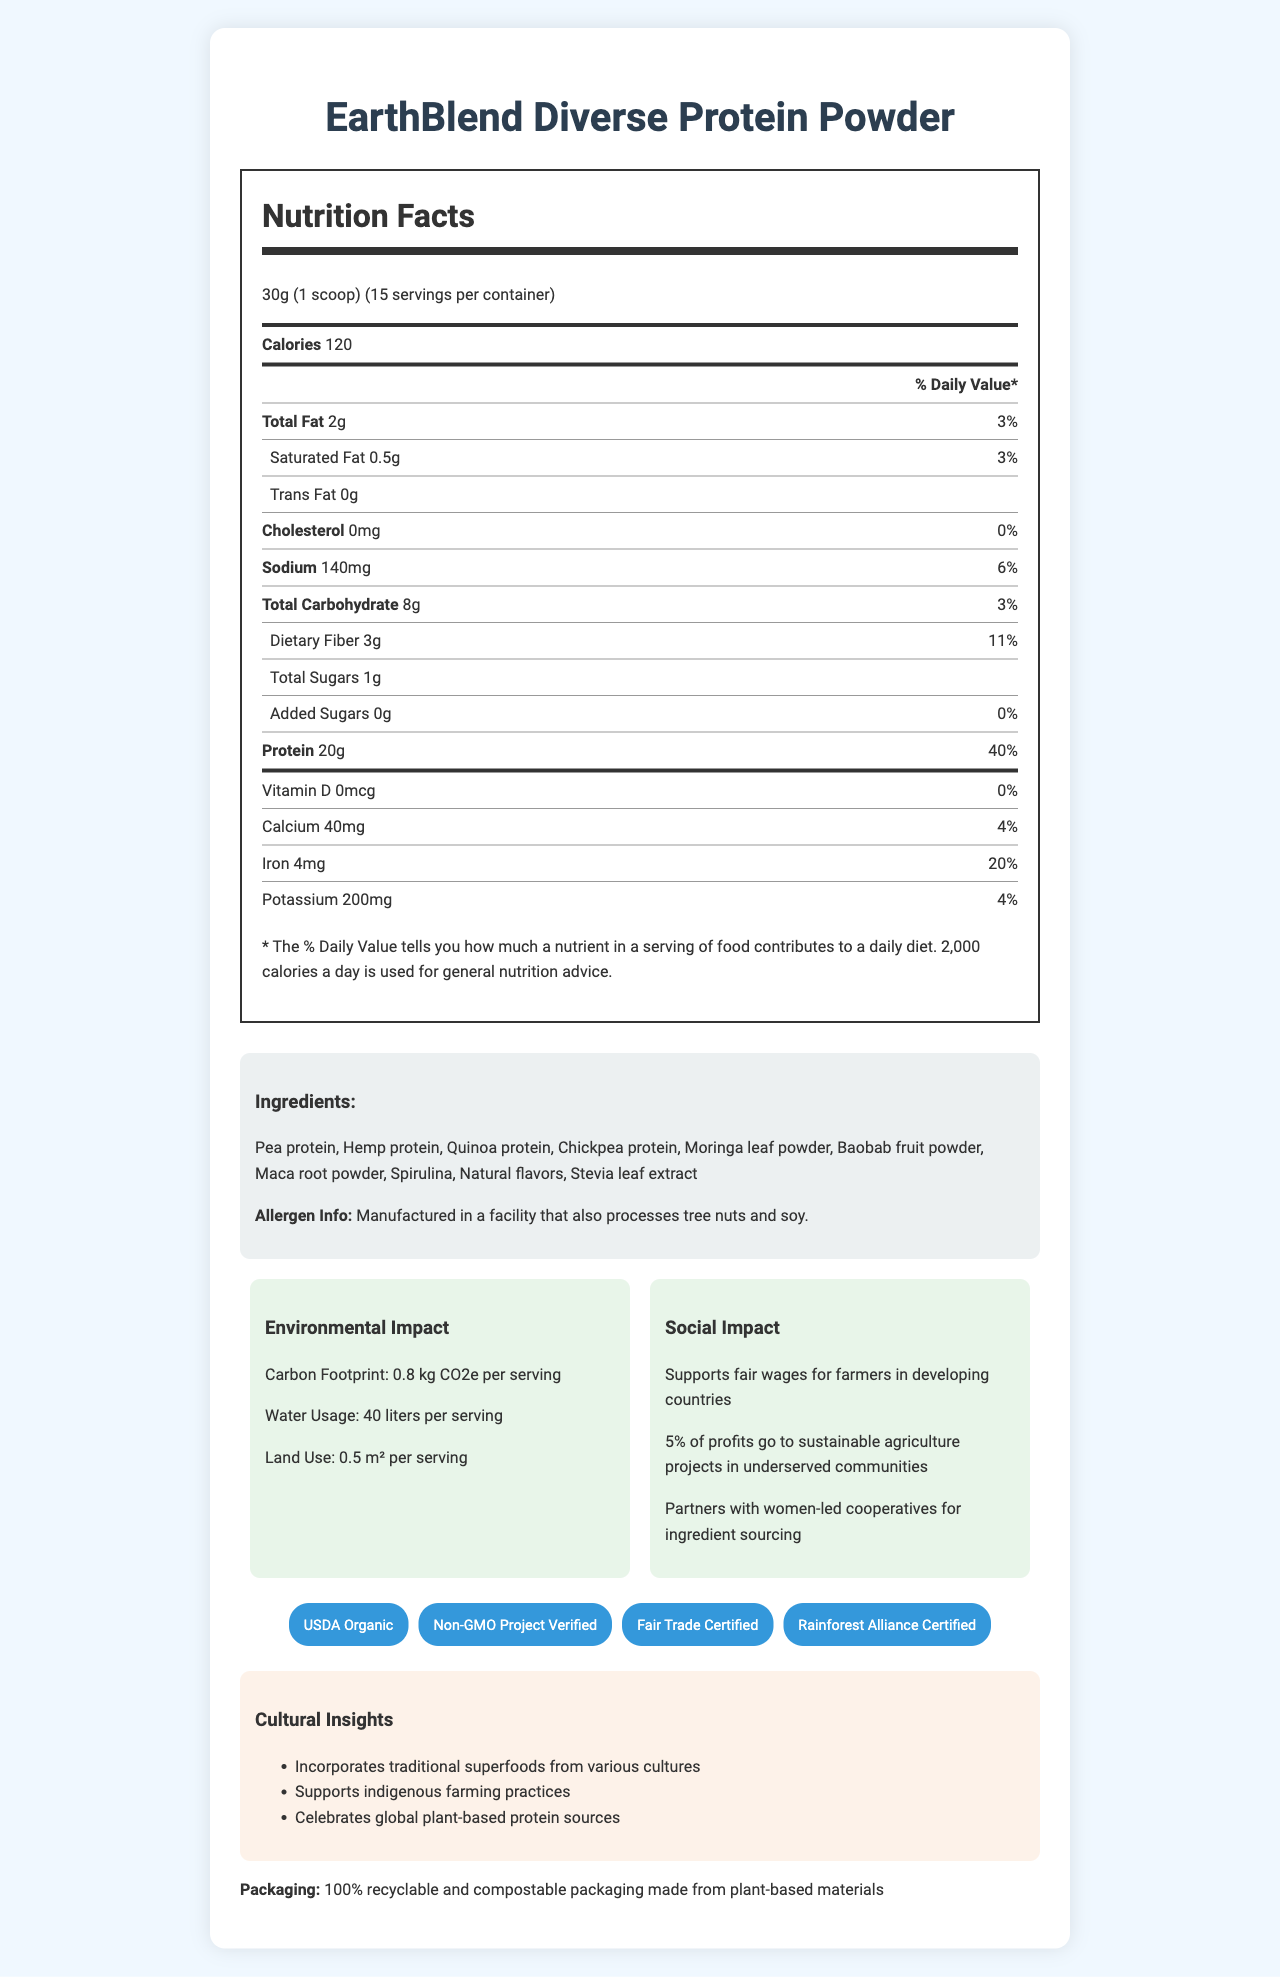what is the product called? The product name "EarthBlend Diverse Protein Powder" is clearly mentioned at the top of the document.
Answer: EarthBlend Diverse Protein Powder How many servings are in one container? The document states that there are 15 servings per container.
Answer: 15 What is the serving size? The serving size is specified as "30g (1 scoop)" in the document.
Answer: 30g (1 scoop) How many calories are there per serving? The document lists the calories per serving as 120.
Answer: 120 How much protein is in each serving? The amount of protein per serving is given as 20g in the document.
Answer: 20g Which dietary fiber percentage of daily value is provided per serving? The dietary fiber content is 3g per serving, which is 11% of the daily value.
Answer: 11% Is there any cholesterol in this product? The document states that the cholesterol amount is "0mg", indicating no cholesterol in the product.
Answer: No What is the carbon footprint per serving? The document mentions that the carbon footprint is "0.8 kg CO2e per serving".
Answer: 0.8 kg CO2e Identify the allergen information provided. The allergen info is clearly noted in the "Ingredients" section of the document.
Answer: Manufactured in a facility that also processes tree nuts and soy. Which one of these ingredients is not included in the product? A. Pea protein B. Hemp protein C. Soy protein The document lists all ingredients except soy protein.
Answer: C How much iron does one serving of the product provide? The document lists iron content as "4mg", which is 20% of the daily value.
Answer: 4mg What percentage of the daily value for calcium does one serving provide? The calcium content is 40mg, which corresponds to 4% of the daily value.
Answer: 4% Which certifications does this product have? A. USDA Organic B. Non-GMO Project Verified C. Fair Trade Certified D. Rainforest Alliance Certified E. All of the above The document lists all these certifications, so the correct answer is all of the above.
Answer: E What is the amount of total fat per serving? The document states that each serving has 2g of total fat.
Answer: 2g Does the product contain added sugars? The added sugars amount is listed as 0g, indicating no added sugars in the product.
Answer: No What initiatives does the product support for social impact? The document details these social impact initiatives in the "Social Impact" section.
Answer: Fair wages for farmers in developing countries, sustainable agriculture projects in underserved communities, and partnering with women-led cooperatives for ingredient sourcing. What type of packaging does this product have? The packaging information specifies that it is fully recyclable and compostable, made from plant-based materials.
Answer: 100% recyclable and compostable packaging made from plant-based materials Summarize the main features of EarthBlend Diverse Protein Powder. The main features include nutrient content, environmental and social impact, certifications, and packaging information, all highlighting the product's commitment to sustainability and social change.
Answer: EarthBlend Diverse Protein Powder is a plant-based protein blend with 20g of protein per serving. It emphasizes sustainability and social responsibility through fair wages, community projects, and partnerships with women-led cooperatives. It has key certifications such as USDA Organic and Non-GMO. Each serving has a carbon footprint of 0.8 kg CO2e, and the packaging is environmentally friendly. What traditional superfoods are included in the ingredients? The section on "Ingredients" lists these traditional superfoods as part of the blend.
Answer: Moringa leaf powder, Baobab fruit powder, Maca root powder, Spirulina Which farming practices does the product support? The document mentions that the product supports indigenous farming practices as part of its cultural insights.
Answer: Indigenous farming practices How much daily value of vitamin D does one serving provide? The document lists vitamin D content as 0mcg, corresponding to 0% of the daily value.
Answer: 0% What is the cost of one container of EarthBlend Diverse Protein Powder? The document does not provide any information about the price.
Answer: Cannot be determined 